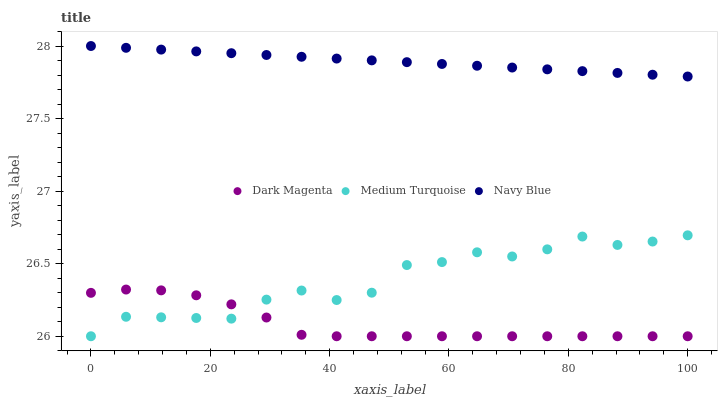Does Dark Magenta have the minimum area under the curve?
Answer yes or no. Yes. Does Navy Blue have the maximum area under the curve?
Answer yes or no. Yes. Does Medium Turquoise have the minimum area under the curve?
Answer yes or no. No. Does Medium Turquoise have the maximum area under the curve?
Answer yes or no. No. Is Navy Blue the smoothest?
Answer yes or no. Yes. Is Medium Turquoise the roughest?
Answer yes or no. Yes. Is Dark Magenta the smoothest?
Answer yes or no. No. Is Dark Magenta the roughest?
Answer yes or no. No. Does Dark Magenta have the lowest value?
Answer yes or no. Yes. Does Navy Blue have the highest value?
Answer yes or no. Yes. Does Medium Turquoise have the highest value?
Answer yes or no. No. Is Medium Turquoise less than Navy Blue?
Answer yes or no. Yes. Is Navy Blue greater than Medium Turquoise?
Answer yes or no. Yes. Does Medium Turquoise intersect Dark Magenta?
Answer yes or no. Yes. Is Medium Turquoise less than Dark Magenta?
Answer yes or no. No. Is Medium Turquoise greater than Dark Magenta?
Answer yes or no. No. Does Medium Turquoise intersect Navy Blue?
Answer yes or no. No. 